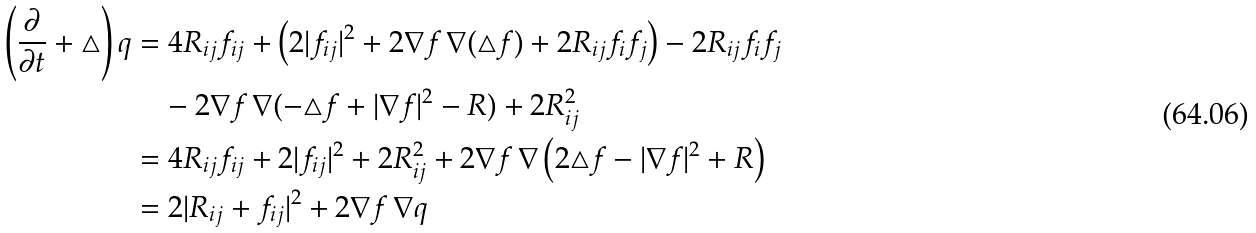<formula> <loc_0><loc_0><loc_500><loc_500>\left ( \frac { \partial } { \partial t } + \triangle \right ) q & = 4 R _ { i j } f _ { i j } + \left ( 2 | f _ { i j } | ^ { 2 } + 2 \nabla f \, \nabla ( \triangle f ) + 2 R _ { i j } f _ { i } f _ { j } \right ) - 2 R _ { i j } f _ { i } f _ { j } \\ & \quad - 2 \nabla f \, \nabla ( - \triangle f + | \nabla f | ^ { 2 } - R ) + 2 R _ { i j } ^ { 2 } \\ & = 4 R _ { i j } f _ { i j } + 2 | f _ { i j } | ^ { 2 } + 2 R _ { i j } ^ { 2 } + 2 \nabla f \, \nabla \left ( 2 \triangle f - | \nabla f | ^ { 2 } + R \right ) \\ & = 2 | R _ { i j } + f _ { i j } | ^ { 2 } + 2 \nabla f \, \nabla q</formula> 